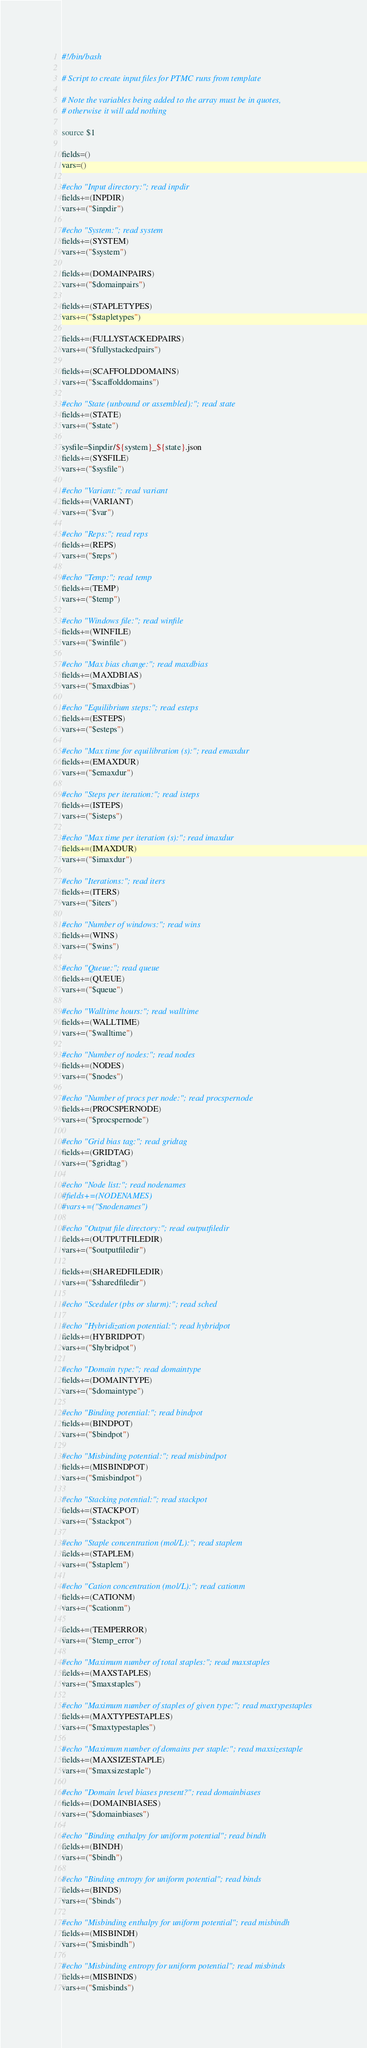Convert code to text. <code><loc_0><loc_0><loc_500><loc_500><_Bash_>#!/bin/bash

# Script to create input files for PTMC runs from template

# Note the variables being added to the array must be in quotes,
# otherwise it will add nothing

source $1

fields=()
vars=()

#echo "Input directory:"; read inpdir
fields+=(INPDIR)
vars+=("$inpdir")

#echo "System:"; read system
fields+=(SYSTEM)
vars+=("$system")

fields+=(DOMAINPAIRS)
vars+=("$domainpairs")

fields+=(STAPLETYPES)
vars+=("$stapletypes")

fields+=(FULLYSTACKEDPAIRS)
vars+=("$fullystackedpairs")

fields+=(SCAFFOLDDOMAINS)
vars+=("$scaffolddomains")

#echo "State (unbound or assembled):"; read state
fields+=(STATE)
vars+=("$state")

sysfile=$inpdir/${system}_${state}.json
fields+=(SYSFILE)
vars+=("$sysfile")

#echo "Variant:"; read variant
fields+=(VARIANT)
vars+=("$var")

#echo "Reps:"; read reps
fields+=(REPS)
vars+=("$reps")

#echo "Temp:"; read temp
fields+=(TEMP)
vars+=("$temp")

#echo "Windows file:"; read winfile
fields+=(WINFILE)
vars+=("$winfile")

#echo "Max bias change:"; read maxdbias
fields+=(MAXDBIAS)
vars+=("$maxdbias")

#echo "Equilibrium steps:"; read esteps
fields+=(ESTEPS)
vars+=("$esteps")

#echo "Max time for equilibration (s):"; read emaxdur
fields+=(EMAXDUR)
vars+=("$emaxdur")

#echo "Steps per iteration:"; read isteps
fields+=(ISTEPS)
vars+=("$isteps")

#echo "Max time per iteration (s):"; read imaxdur
fields+=(IMAXDUR)
vars+=("$imaxdur")

#echo "Iterations:"; read iters
fields+=(ITERS)
vars+=("$iters")

#echo "Number of windows:"; read wins
fields+=(WINS)
vars+=("$wins")

#echo "Queue:"; read queue
fields+=(QUEUE)
vars+=("$queue")

#echo "Walltime hours:"; read walltime
fields+=(WALLTIME)
vars+=("$walltime")

#echo "Number of nodes:"; read nodes
fields+=(NODES)
vars+=("$nodes")

#echo "Number of procs per node:"; read procspernode
fields+=(PROCSPERNODE)
vars+=("$procspernode")

#echo "Grid bias tag:"; read gridtag
fields+=(GRIDTAG)
vars+=("$gridtag")

#echo "Node list:"; read nodenames
#fields+=(NODENAMES)
#vars+=("$nodenames")

#echo "Output file directory:"; read outputfiledir
fields+=(OUTPUTFILEDIR)
vars+=("$outputfiledir")

fields+=(SHAREDFILEDIR)
vars+=("$sharedfiledir")

#echo "Sceduler (pbs or slurm):"; read sched

#echo "Hybridization potential:"; read hybridpot
fields+=(HYBRIDPOT)
vars+=("$hybridpot")

#echo "Domain type:"; read domaintype
fields+=(DOMAINTYPE)
vars+=("$domaintype")

#echo "Binding potential:"; read bindpot
fields+=(BINDPOT)
vars+=("$bindpot")

#echo "Misbinding potential:"; read misbindpot
fields+=(MISBINDPOT)
vars+=("$misbindpot")

#echo "Stacking potential:"; read stackpot
fields+=(STACKPOT)
vars+=("$stackpot")

#echo "Staple concentration (mol/L):"; read staplem
fields+=(STAPLEM)
vars+=("$staplem")

#echo "Cation concentration (mol/L):"; read cationm
fields+=(CATIONM)
vars+=("$cationm")

fields+=(TEMPERROR)
vars+=("$temp_error")

#echo "Maximum number of total staples:"; read maxstaples
fields+=(MAXSTAPLES)
vars+=("$maxstaples")

#echo "Maximum number of staples of given type:"; read maxtypestaples
fields+=(MAXTYPESTAPLES)
vars+=("$maxtypestaples")

#echo "Maximum number of domains per staple:"; read maxsizestaple
fields+=(MAXSIZESTAPLE)
vars+=("$maxsizestaple")

#echo "Domain level biases present?"; read domainbiases
fields+=(DOMAINBIASES)
vars+=("$domainbiases")

#echo "Binding enthalpy for uniform potential"; read bindh
fields+=(BINDH)
vars+=("$bindh")

#echo "Binding entropy for uniform potential"; read binds
fields+=(BINDS)
vars+=("$binds")

#echo "Misbinding enthalpy for uniform potential"; read misbindh
fields+=(MISBINDH)
vars+=("$misbindh")

#echo "Misbinding entropy for uniform potential"; read misbinds
fields+=(MISBINDS)
vars+=("$misbinds")
</code> 